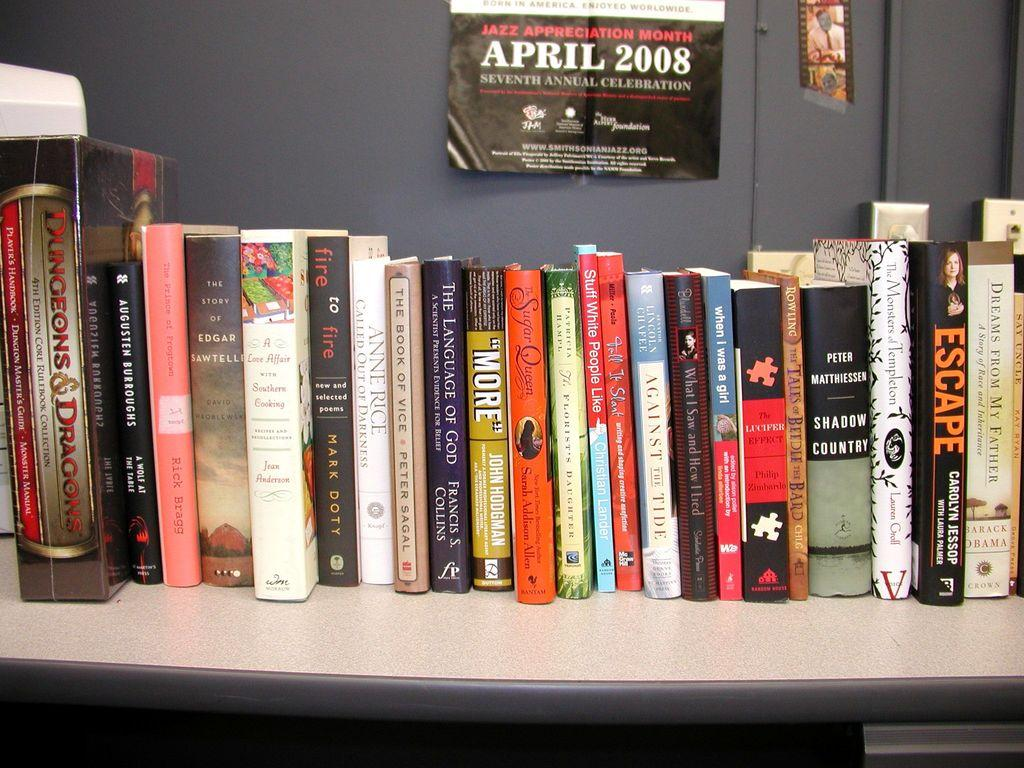<image>
Render a clear and concise summary of the photo. A bunch of books sit on a shelf below a poster that reads April 2008. 